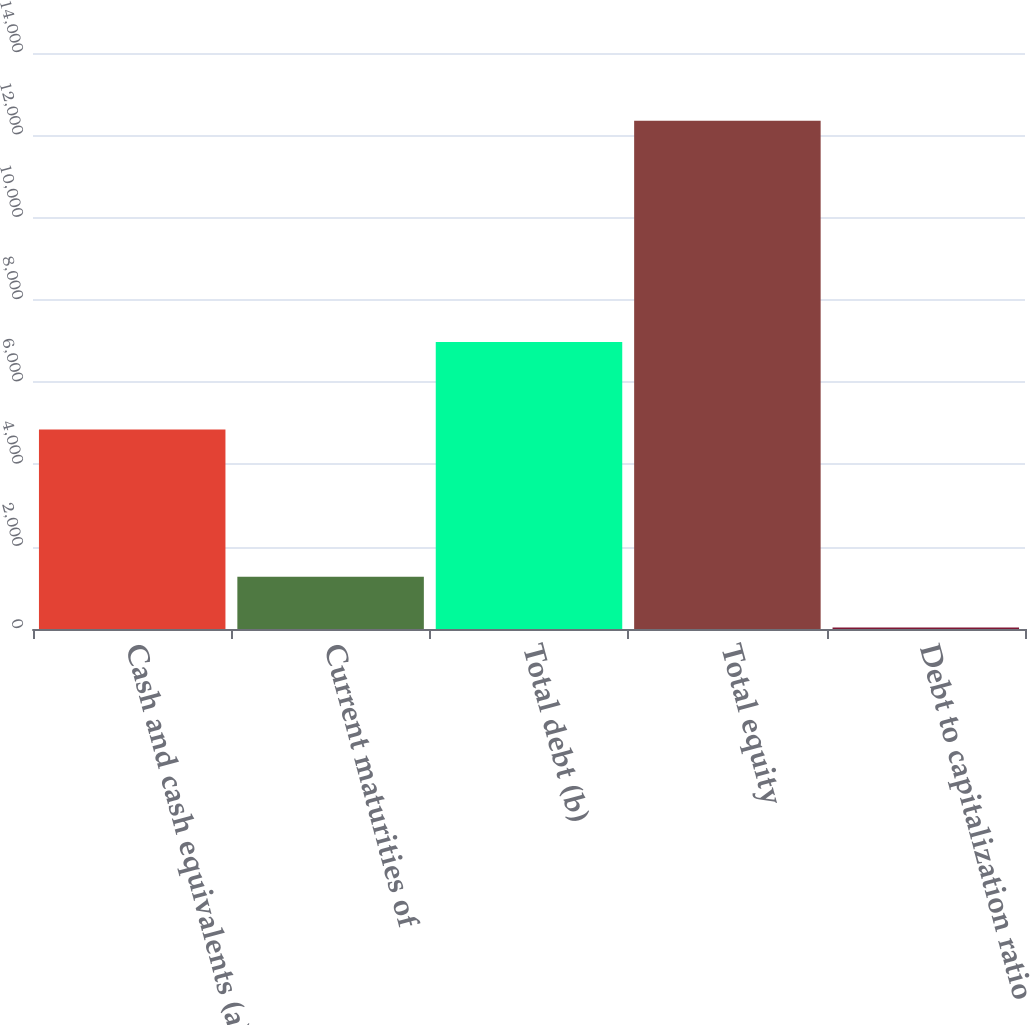<chart> <loc_0><loc_0><loc_500><loc_500><bar_chart><fcel>Cash and cash equivalents (a)<fcel>Current maturities of<fcel>Total debt (b)<fcel>Total equity<fcel>Debt to capitalization ratio<nl><fcel>4847<fcel>1267.89<fcel>6977<fcel>12354<fcel>36.1<nl></chart> 